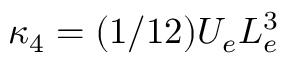<formula> <loc_0><loc_0><loc_500><loc_500>\kappa _ { 4 } = ( 1 / 1 2 ) U _ { e } L _ { e } ^ { 3 }</formula> 